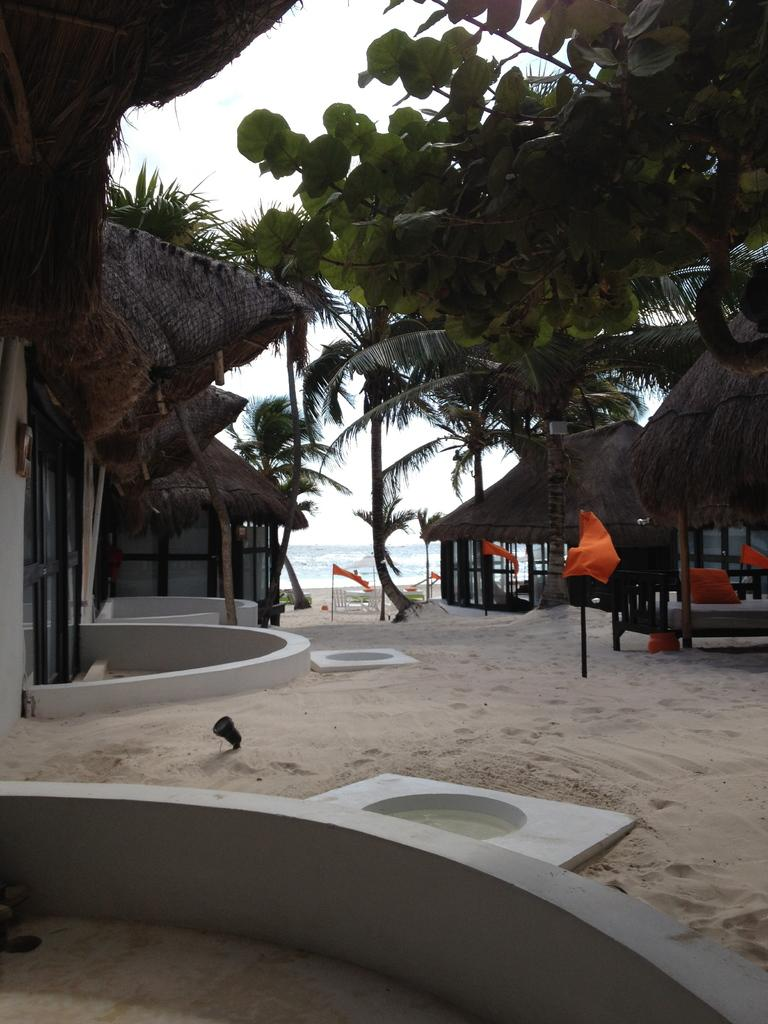What type of structures are present in the image? There are huts in the image. What type of vegetation can be seen in the image? There are trees in the image. What objects are used to display flags in the image? There are flags with poles in the image. What type of ground is visible in the image? The ground is covered with sand. What can be seen in the distance in the image? There is water visible in the background of the image. What is visible above the huts and trees in the image? The sky is visible in the background of the image. What type of instrument can be seen being played by the huts? There are no instruments visible in the image, as it features huts, trees, flags, sand, water, and sky. 